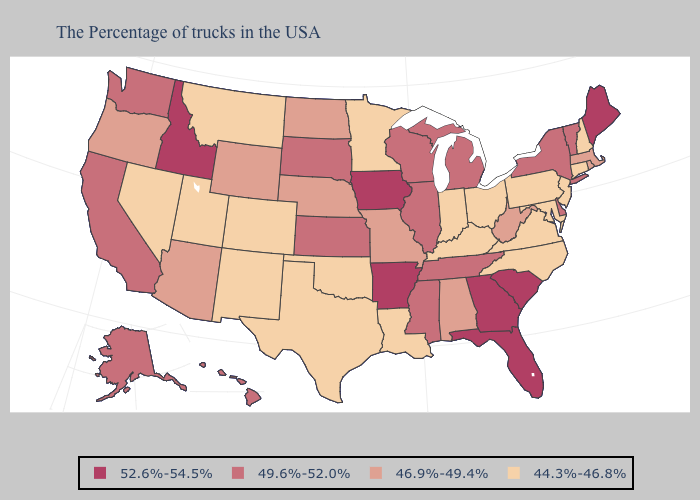Which states have the lowest value in the USA?
Give a very brief answer. New Hampshire, Connecticut, New Jersey, Maryland, Pennsylvania, Virginia, North Carolina, Ohio, Kentucky, Indiana, Louisiana, Minnesota, Oklahoma, Texas, Colorado, New Mexico, Utah, Montana, Nevada. Is the legend a continuous bar?
Keep it brief. No. What is the highest value in the USA?
Quick response, please. 52.6%-54.5%. Which states have the lowest value in the Northeast?
Write a very short answer. New Hampshire, Connecticut, New Jersey, Pennsylvania. What is the value of Oregon?
Give a very brief answer. 46.9%-49.4%. Does the first symbol in the legend represent the smallest category?
Write a very short answer. No. Does Pennsylvania have a higher value than Wyoming?
Write a very short answer. No. Name the states that have a value in the range 46.9%-49.4%?
Give a very brief answer. Massachusetts, Rhode Island, West Virginia, Alabama, Missouri, Nebraska, North Dakota, Wyoming, Arizona, Oregon. Which states have the highest value in the USA?
Answer briefly. Maine, South Carolina, Florida, Georgia, Arkansas, Iowa, Idaho. How many symbols are there in the legend?
Concise answer only. 4. What is the highest value in the MidWest ?
Answer briefly. 52.6%-54.5%. What is the value of West Virginia?
Concise answer only. 46.9%-49.4%. Does Connecticut have the lowest value in the USA?
Give a very brief answer. Yes. Does Idaho have a higher value than Maine?
Give a very brief answer. No. Does Arizona have a higher value than Nevada?
Be succinct. Yes. 